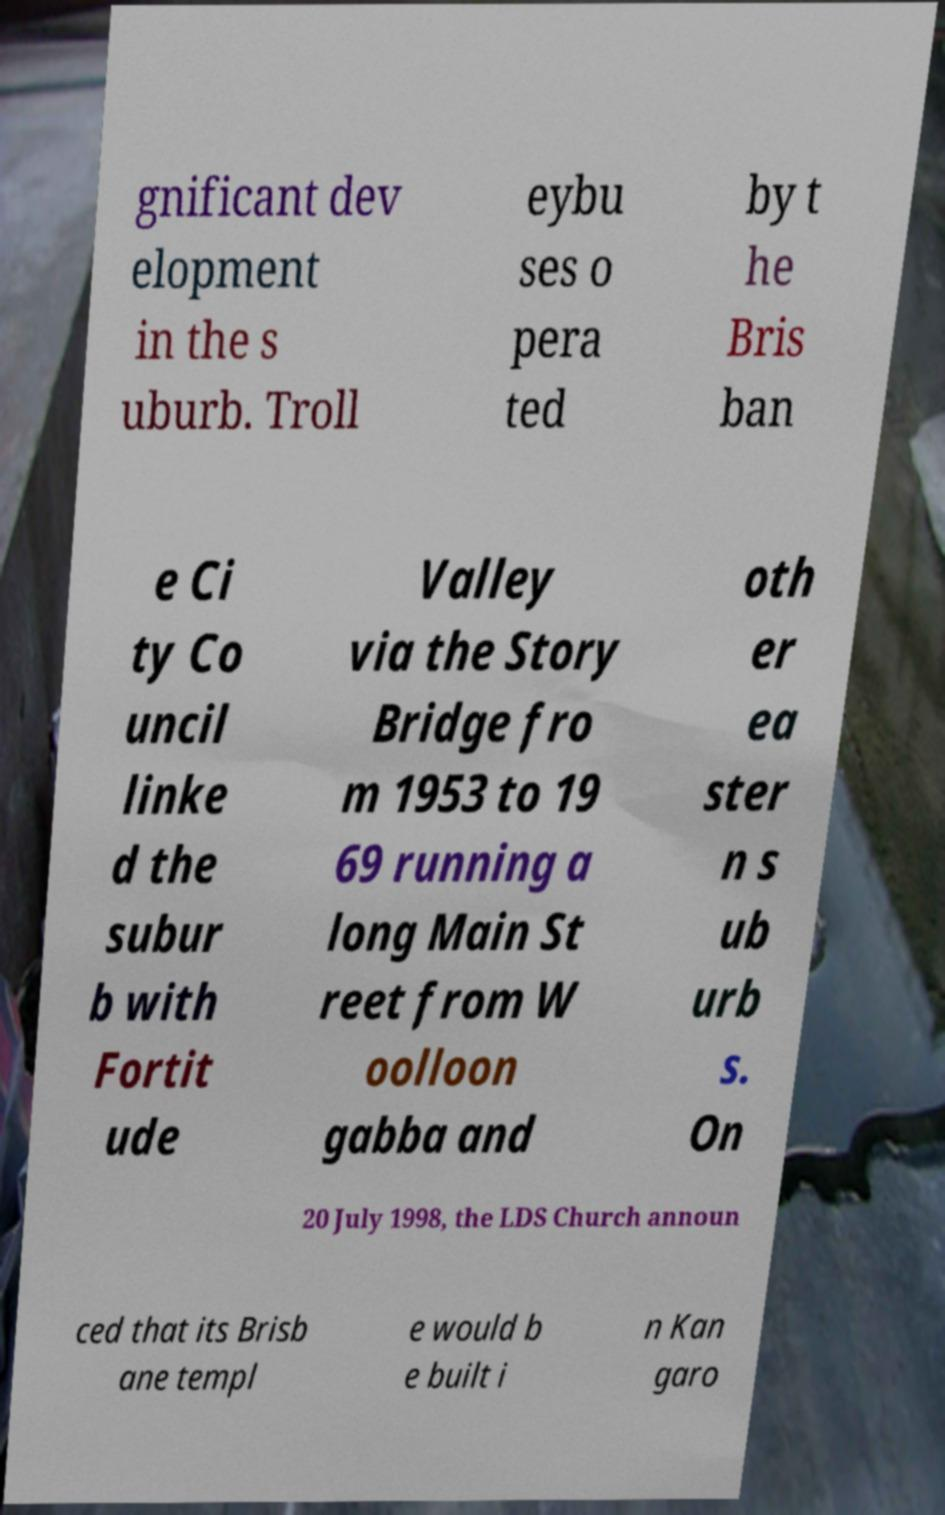What messages or text are displayed in this image? I need them in a readable, typed format. gnificant dev elopment in the s uburb. Troll eybu ses o pera ted by t he Bris ban e Ci ty Co uncil linke d the subur b with Fortit ude Valley via the Story Bridge fro m 1953 to 19 69 running a long Main St reet from W oolloon gabba and oth er ea ster n s ub urb s. On 20 July 1998, the LDS Church announ ced that its Brisb ane templ e would b e built i n Kan garo 